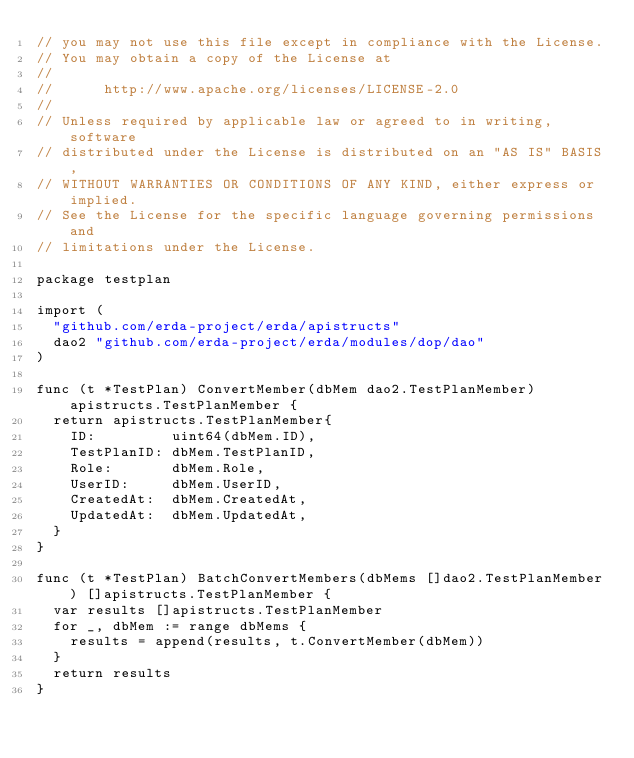<code> <loc_0><loc_0><loc_500><loc_500><_Go_>// you may not use this file except in compliance with the License.
// You may obtain a copy of the License at
//
//      http://www.apache.org/licenses/LICENSE-2.0
//
// Unless required by applicable law or agreed to in writing, software
// distributed under the License is distributed on an "AS IS" BASIS,
// WITHOUT WARRANTIES OR CONDITIONS OF ANY KIND, either express or implied.
// See the License for the specific language governing permissions and
// limitations under the License.

package testplan

import (
	"github.com/erda-project/erda/apistructs"
	dao2 "github.com/erda-project/erda/modules/dop/dao"
)

func (t *TestPlan) ConvertMember(dbMem dao2.TestPlanMember) apistructs.TestPlanMember {
	return apistructs.TestPlanMember{
		ID:         uint64(dbMem.ID),
		TestPlanID: dbMem.TestPlanID,
		Role:       dbMem.Role,
		UserID:     dbMem.UserID,
		CreatedAt:  dbMem.CreatedAt,
		UpdatedAt:  dbMem.UpdatedAt,
	}
}

func (t *TestPlan) BatchConvertMembers(dbMems []dao2.TestPlanMember) []apistructs.TestPlanMember {
	var results []apistructs.TestPlanMember
	for _, dbMem := range dbMems {
		results = append(results, t.ConvertMember(dbMem))
	}
	return results
}
</code> 